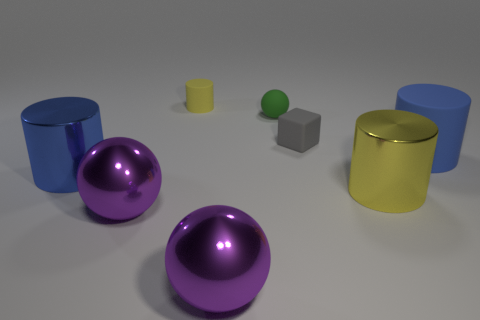What number of yellow objects are rubber cylinders or metal cylinders?
Your response must be concise. 2. What number of purple shiny blocks have the same size as the rubber ball?
Your answer should be compact. 0. Do the big blue thing to the left of the green object and the tiny green ball have the same material?
Provide a short and direct response. No. Is there a blue cylinder that is behind the large blue object on the right side of the yellow matte cylinder?
Offer a terse response. No. There is a tiny yellow object that is the same shape as the large yellow shiny object; what is it made of?
Your response must be concise. Rubber. Are there more blue objects that are on the left side of the big blue metal thing than small gray rubber cubes that are to the left of the small green object?
Provide a short and direct response. No. What shape is the blue thing that is the same material as the small yellow cylinder?
Provide a short and direct response. Cylinder. Is the number of large yellow things left of the blue metallic object greater than the number of big purple objects?
Provide a succinct answer. No. How many rubber things are the same color as the small ball?
Provide a short and direct response. 0. How many other objects are the same color as the small cylinder?
Make the answer very short. 1. 